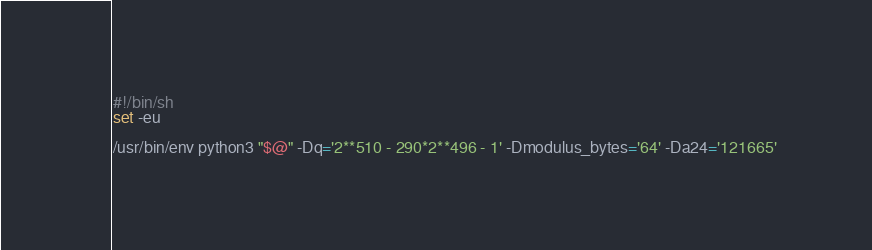<code> <loc_0><loc_0><loc_500><loc_500><_Bash_>#!/bin/sh
set -eu

/usr/bin/env python3 "$@" -Dq='2**510 - 290*2**496 - 1' -Dmodulus_bytes='64' -Da24='121665'
</code> 